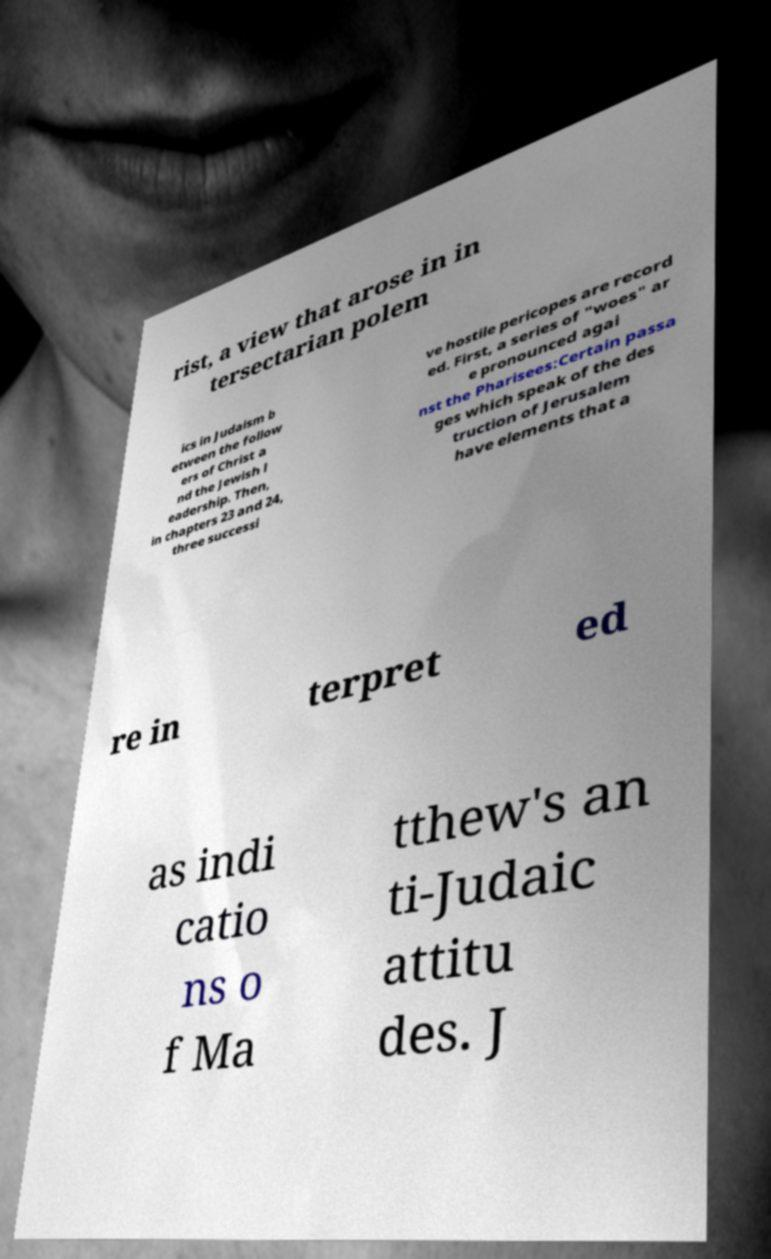There's text embedded in this image that I need extracted. Can you transcribe it verbatim? rist, a view that arose in in tersectarian polem ics in Judaism b etween the follow ers of Christ a nd the Jewish l eadership. Then, in chapters 23 and 24, three successi ve hostile pericopes are record ed. First, a series of "woes" ar e pronounced agai nst the Pharisees:Certain passa ges which speak of the des truction of Jerusalem have elements that a re in terpret ed as indi catio ns o f Ma tthew's an ti-Judaic attitu des. J 